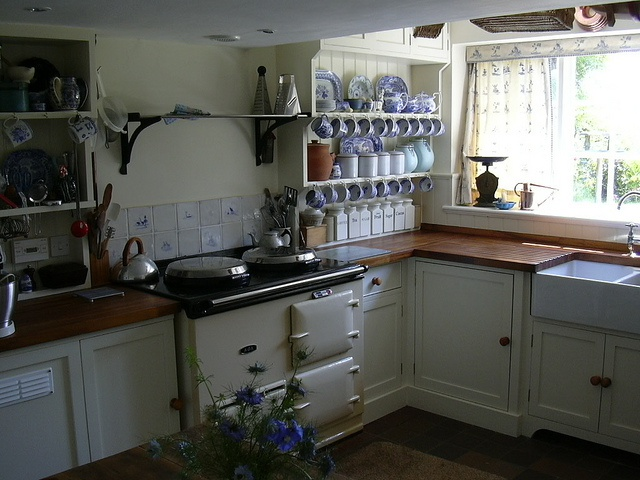Describe the objects in this image and their specific colors. I can see cup in black, gray, darkgray, and lightgray tones, oven in black and gray tones, potted plant in black, gray, and navy tones, sink in black, purple, and darkgray tones, and bowl in black, gray, darkgray, and lightblue tones in this image. 